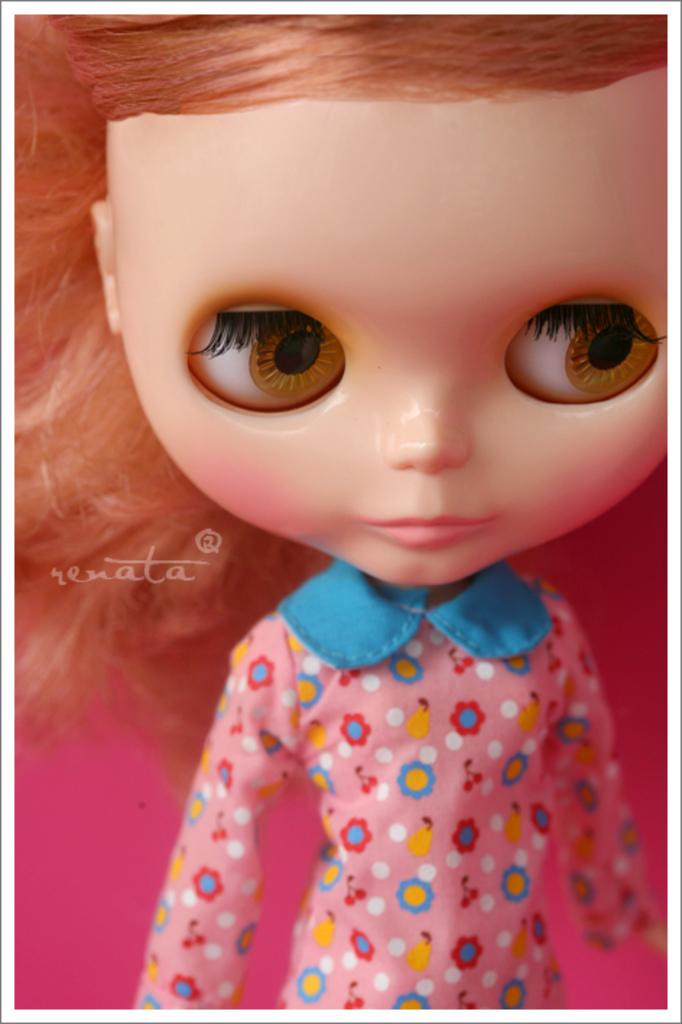What object in the image is designed for play or entertainment? There is a toy in the image. What type of quartz is used to build the toy in the image? There is no mention of quartz or any building materials in the image, as it only features a toy. 